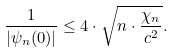<formula> <loc_0><loc_0><loc_500><loc_500>\frac { 1 } { | \psi _ { n } ( 0 ) | } \leq 4 \cdot \sqrt { n \cdot \frac { \chi _ { n } } { c ^ { 2 } } } .</formula> 